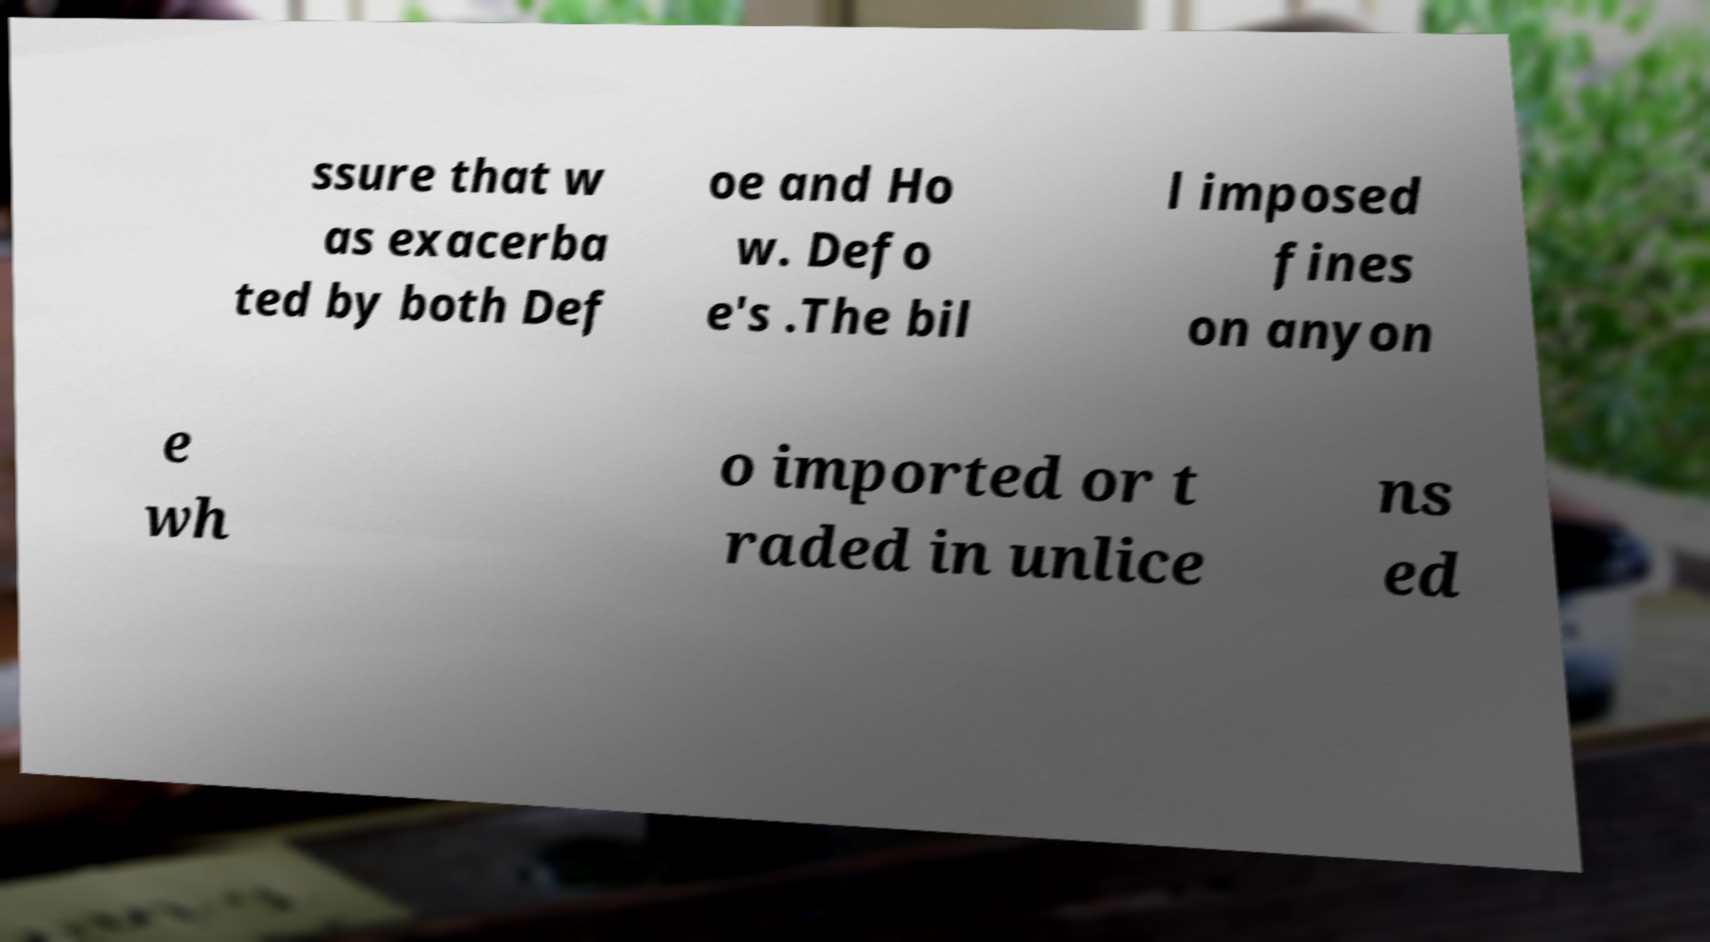Can you read and provide the text displayed in the image?This photo seems to have some interesting text. Can you extract and type it out for me? ssure that w as exacerba ted by both Def oe and Ho w. Defo e's .The bil l imposed fines on anyon e wh o imported or t raded in unlice ns ed 